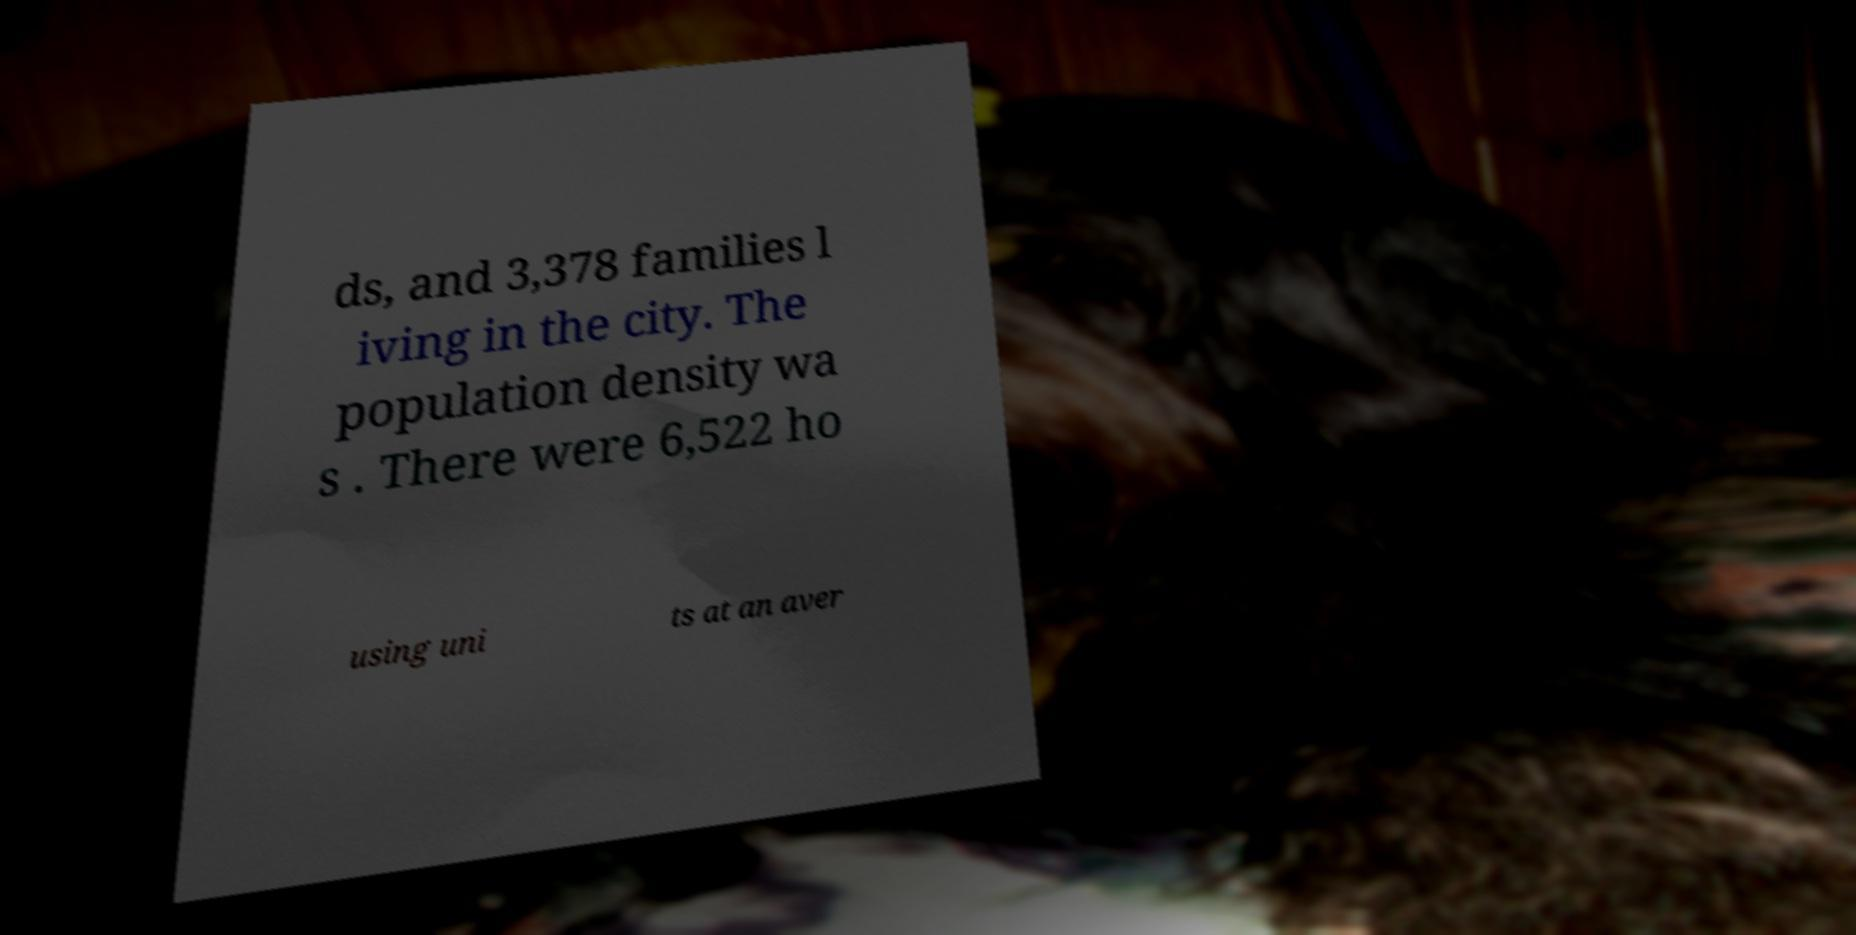Please read and relay the text visible in this image. What does it say? ds, and 3,378 families l iving in the city. The population density wa s . There were 6,522 ho using uni ts at an aver 